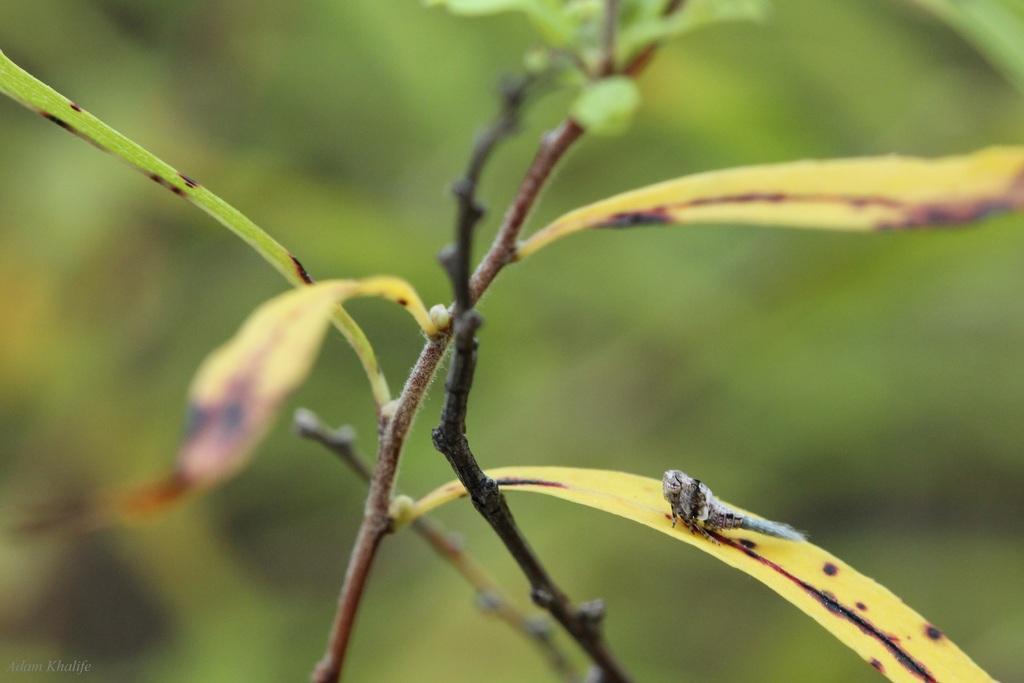In one or two sentences, can you explain what this image depicts? In this image in the front there is a plant and the background is blurry. 